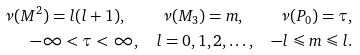<formula> <loc_0><loc_0><loc_500><loc_500>\nu ( M ^ { 2 } ) = l ( l + 1 ) , \quad \nu ( M _ { 3 } ) = m , \quad \nu ( P _ { 0 } ) = \tau , \\ - \infty < \tau < \infty , \quad l = 0 , 1 , 2 , \dots , \quad - l \leqslant m \leqslant l .</formula> 